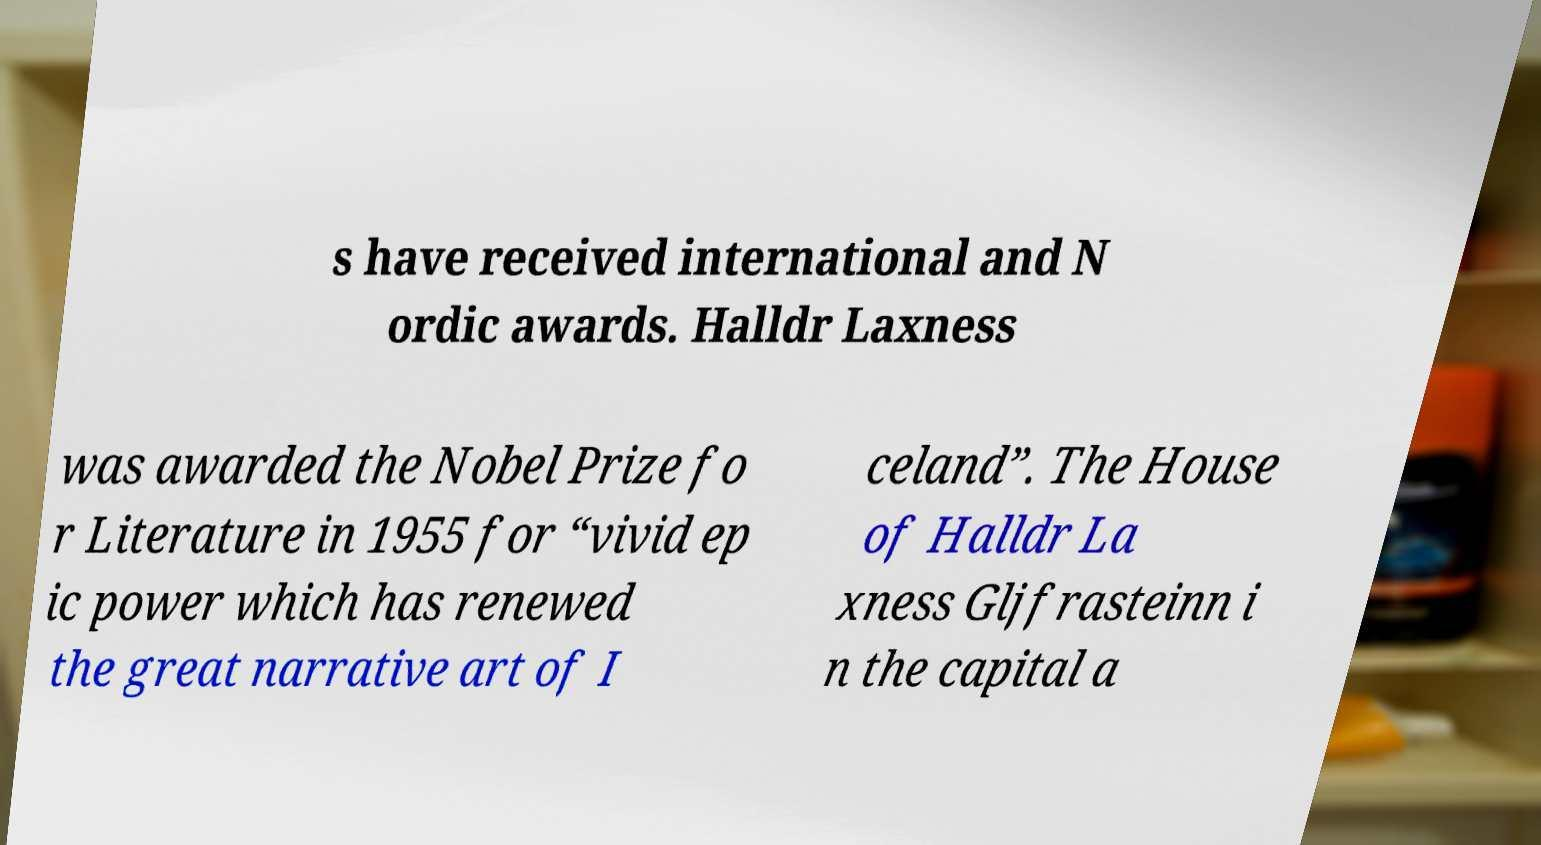I need the written content from this picture converted into text. Can you do that? s have received international and N ordic awards. Halldr Laxness was awarded the Nobel Prize fo r Literature in 1955 for “vivid ep ic power which has renewed the great narrative art of I celand”. The House of Halldr La xness Gljfrasteinn i n the capital a 